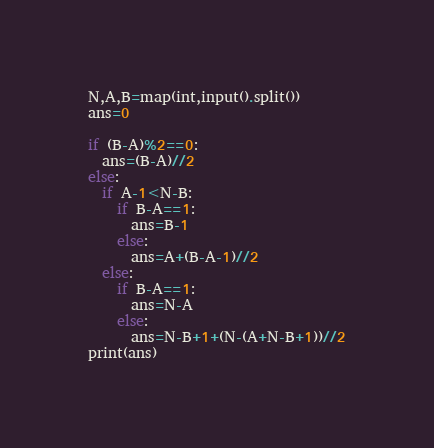<code> <loc_0><loc_0><loc_500><loc_500><_Python_>N,A,B=map(int,input().split())
ans=0
 
if (B-A)%2==0:
  ans=(B-A)//2
else:
  if A-1<N-B:
    if B-A==1:
      ans=B-1
    else:
      ans=A+(B-A-1)//2
  else:
    if B-A==1:
      ans=N-A
    else:
      ans=N-B+1+(N-(A+N-B+1))//2
print(ans)</code> 